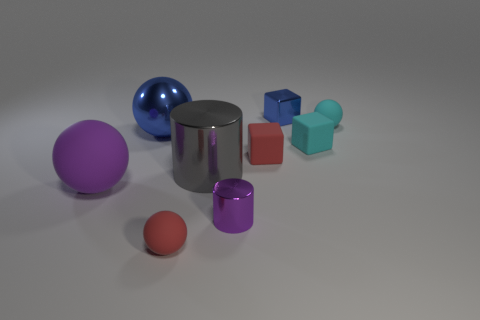Subtract all red matte blocks. How many blocks are left? 2 Subtract all red spheres. How many spheres are left? 3 Subtract all cylinders. How many objects are left? 7 Add 1 big yellow balls. How many objects exist? 10 Subtract 3 cubes. How many cubes are left? 0 Add 8 small metal cylinders. How many small metal cylinders are left? 9 Add 7 tiny cylinders. How many tiny cylinders exist? 8 Subtract 0 brown cubes. How many objects are left? 9 Subtract all brown cubes. Subtract all gray balls. How many cubes are left? 3 Subtract all red cylinders. How many blue balls are left? 1 